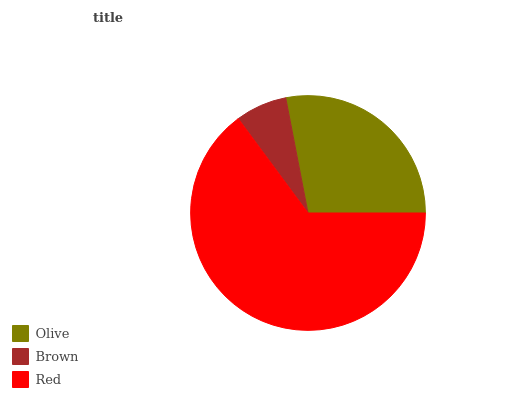Is Brown the minimum?
Answer yes or no. Yes. Is Red the maximum?
Answer yes or no. Yes. Is Red the minimum?
Answer yes or no. No. Is Brown the maximum?
Answer yes or no. No. Is Red greater than Brown?
Answer yes or no. Yes. Is Brown less than Red?
Answer yes or no. Yes. Is Brown greater than Red?
Answer yes or no. No. Is Red less than Brown?
Answer yes or no. No. Is Olive the high median?
Answer yes or no. Yes. Is Olive the low median?
Answer yes or no. Yes. Is Red the high median?
Answer yes or no. No. Is Brown the low median?
Answer yes or no. No. 